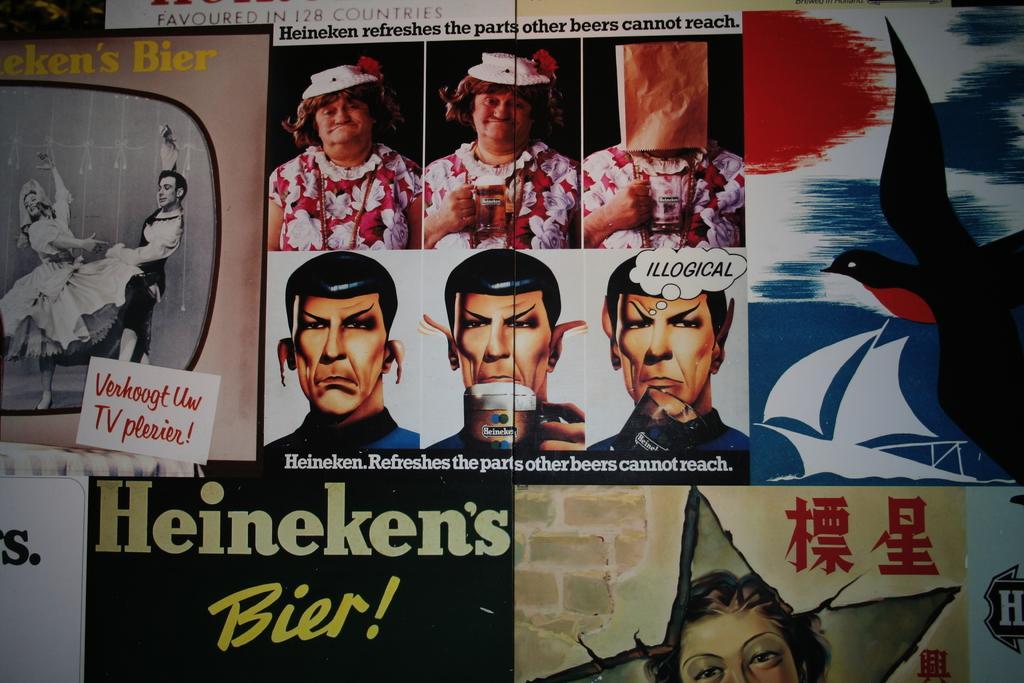In one or two sentences, can you explain what this image depicts? In this image I see number of posters on which I see pictures of persons and I see depiction of a bird and few more people and I see something is written. 